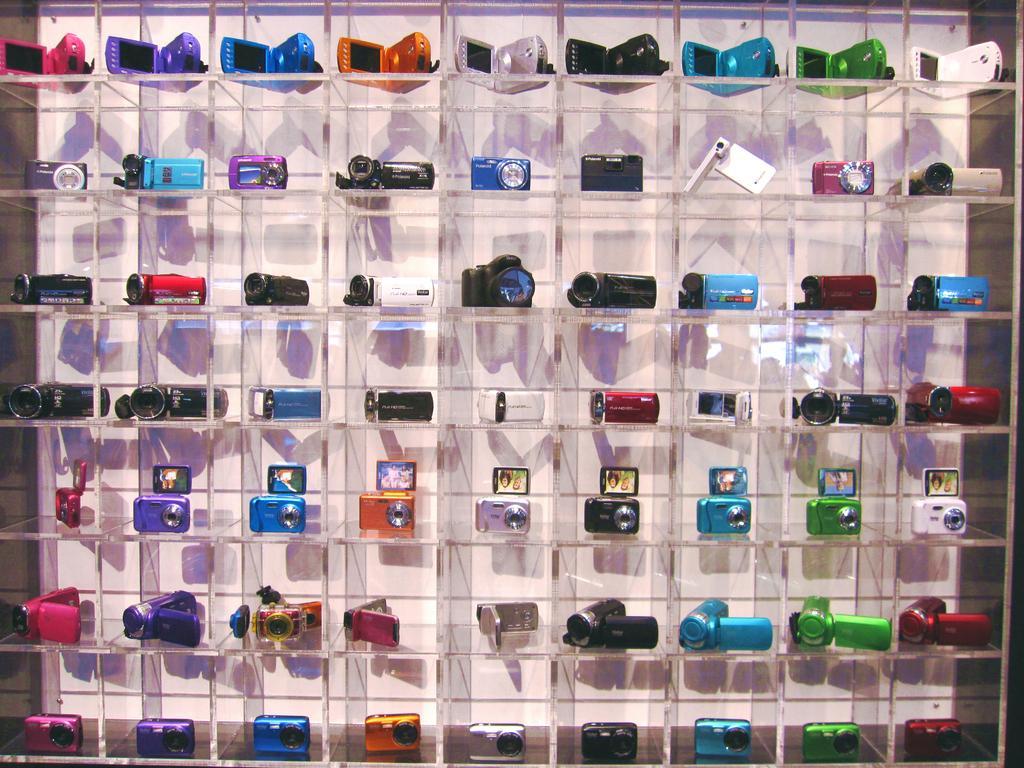Can you describe this image briefly? In this image there are so many cameras arranged in the rack. 